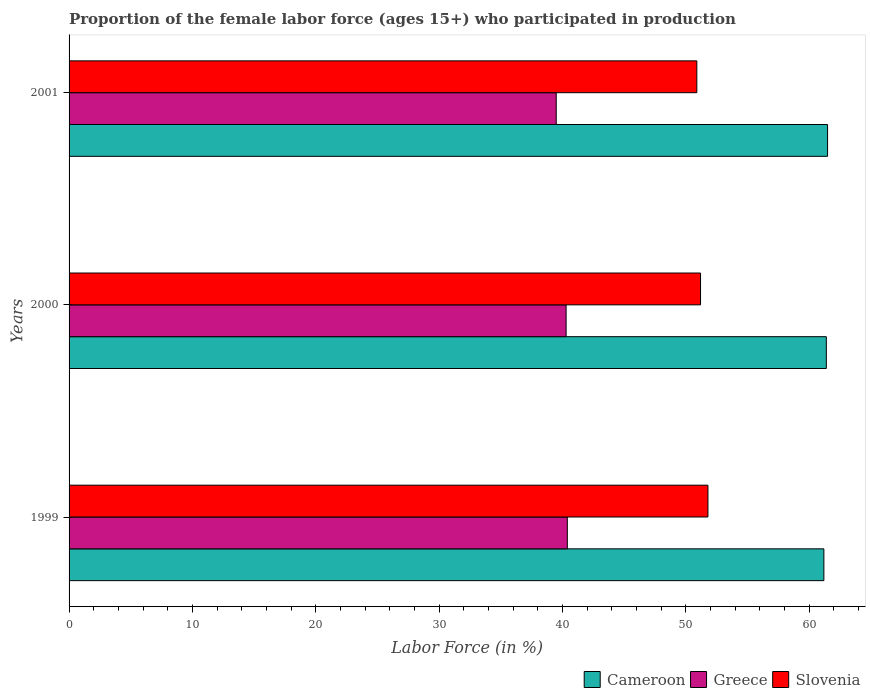How many groups of bars are there?
Make the answer very short. 3. Are the number of bars per tick equal to the number of legend labels?
Your answer should be very brief. Yes. How many bars are there on the 1st tick from the top?
Keep it short and to the point. 3. How many bars are there on the 2nd tick from the bottom?
Offer a terse response. 3. What is the label of the 2nd group of bars from the top?
Provide a short and direct response. 2000. What is the proportion of the female labor force who participated in production in Cameroon in 1999?
Provide a succinct answer. 61.2. Across all years, what is the maximum proportion of the female labor force who participated in production in Cameroon?
Make the answer very short. 61.5. Across all years, what is the minimum proportion of the female labor force who participated in production in Greece?
Make the answer very short. 39.5. In which year was the proportion of the female labor force who participated in production in Greece minimum?
Your answer should be compact. 2001. What is the total proportion of the female labor force who participated in production in Slovenia in the graph?
Ensure brevity in your answer.  153.9. What is the difference between the proportion of the female labor force who participated in production in Greece in 1999 and that in 2001?
Offer a very short reply. 0.9. What is the difference between the proportion of the female labor force who participated in production in Cameroon in 2000 and the proportion of the female labor force who participated in production in Slovenia in 1999?
Provide a short and direct response. 9.6. What is the average proportion of the female labor force who participated in production in Slovenia per year?
Provide a short and direct response. 51.3. In the year 1999, what is the difference between the proportion of the female labor force who participated in production in Greece and proportion of the female labor force who participated in production in Slovenia?
Ensure brevity in your answer.  -11.4. In how many years, is the proportion of the female labor force who participated in production in Greece greater than 24 %?
Keep it short and to the point. 3. What is the ratio of the proportion of the female labor force who participated in production in Slovenia in 2000 to that in 2001?
Keep it short and to the point. 1.01. Is the proportion of the female labor force who participated in production in Slovenia in 2000 less than that in 2001?
Your answer should be very brief. No. What is the difference between the highest and the second highest proportion of the female labor force who participated in production in Cameroon?
Offer a terse response. 0.1. What is the difference between the highest and the lowest proportion of the female labor force who participated in production in Slovenia?
Offer a terse response. 0.9. Is the sum of the proportion of the female labor force who participated in production in Slovenia in 2000 and 2001 greater than the maximum proportion of the female labor force who participated in production in Cameroon across all years?
Your response must be concise. Yes. What does the 2nd bar from the top in 2000 represents?
Offer a very short reply. Greece. What does the 1st bar from the bottom in 2001 represents?
Your answer should be very brief. Cameroon. Is it the case that in every year, the sum of the proportion of the female labor force who participated in production in Slovenia and proportion of the female labor force who participated in production in Cameroon is greater than the proportion of the female labor force who participated in production in Greece?
Your response must be concise. Yes. How many years are there in the graph?
Ensure brevity in your answer.  3. What is the difference between two consecutive major ticks on the X-axis?
Provide a succinct answer. 10. How many legend labels are there?
Your answer should be very brief. 3. What is the title of the graph?
Give a very brief answer. Proportion of the female labor force (ages 15+) who participated in production. Does "India" appear as one of the legend labels in the graph?
Your answer should be compact. No. What is the label or title of the X-axis?
Your answer should be compact. Labor Force (in %). What is the Labor Force (in %) of Cameroon in 1999?
Your answer should be very brief. 61.2. What is the Labor Force (in %) of Greece in 1999?
Offer a terse response. 40.4. What is the Labor Force (in %) in Slovenia in 1999?
Your answer should be very brief. 51.8. What is the Labor Force (in %) of Cameroon in 2000?
Offer a terse response. 61.4. What is the Labor Force (in %) in Greece in 2000?
Make the answer very short. 40.3. What is the Labor Force (in %) of Slovenia in 2000?
Offer a terse response. 51.2. What is the Labor Force (in %) of Cameroon in 2001?
Offer a very short reply. 61.5. What is the Labor Force (in %) in Greece in 2001?
Provide a short and direct response. 39.5. What is the Labor Force (in %) in Slovenia in 2001?
Your answer should be compact. 50.9. Across all years, what is the maximum Labor Force (in %) of Cameroon?
Your response must be concise. 61.5. Across all years, what is the maximum Labor Force (in %) of Greece?
Provide a succinct answer. 40.4. Across all years, what is the maximum Labor Force (in %) in Slovenia?
Give a very brief answer. 51.8. Across all years, what is the minimum Labor Force (in %) of Cameroon?
Offer a very short reply. 61.2. Across all years, what is the minimum Labor Force (in %) in Greece?
Your response must be concise. 39.5. Across all years, what is the minimum Labor Force (in %) in Slovenia?
Keep it short and to the point. 50.9. What is the total Labor Force (in %) in Cameroon in the graph?
Your answer should be compact. 184.1. What is the total Labor Force (in %) of Greece in the graph?
Offer a terse response. 120.2. What is the total Labor Force (in %) of Slovenia in the graph?
Your response must be concise. 153.9. What is the difference between the Labor Force (in %) of Greece in 1999 and that in 2001?
Provide a succinct answer. 0.9. What is the difference between the Labor Force (in %) in Slovenia in 1999 and that in 2001?
Keep it short and to the point. 0.9. What is the difference between the Labor Force (in %) of Greece in 2000 and that in 2001?
Give a very brief answer. 0.8. What is the difference between the Labor Force (in %) in Slovenia in 2000 and that in 2001?
Provide a succinct answer. 0.3. What is the difference between the Labor Force (in %) of Cameroon in 1999 and the Labor Force (in %) of Greece in 2000?
Provide a short and direct response. 20.9. What is the difference between the Labor Force (in %) in Cameroon in 1999 and the Labor Force (in %) in Slovenia in 2000?
Your answer should be compact. 10. What is the difference between the Labor Force (in %) in Greece in 1999 and the Labor Force (in %) in Slovenia in 2000?
Provide a succinct answer. -10.8. What is the difference between the Labor Force (in %) of Cameroon in 1999 and the Labor Force (in %) of Greece in 2001?
Provide a succinct answer. 21.7. What is the difference between the Labor Force (in %) in Greece in 1999 and the Labor Force (in %) in Slovenia in 2001?
Your answer should be very brief. -10.5. What is the difference between the Labor Force (in %) of Cameroon in 2000 and the Labor Force (in %) of Greece in 2001?
Offer a very short reply. 21.9. What is the difference between the Labor Force (in %) of Greece in 2000 and the Labor Force (in %) of Slovenia in 2001?
Provide a short and direct response. -10.6. What is the average Labor Force (in %) in Cameroon per year?
Provide a short and direct response. 61.37. What is the average Labor Force (in %) of Greece per year?
Your answer should be compact. 40.07. What is the average Labor Force (in %) in Slovenia per year?
Make the answer very short. 51.3. In the year 1999, what is the difference between the Labor Force (in %) in Cameroon and Labor Force (in %) in Greece?
Make the answer very short. 20.8. In the year 1999, what is the difference between the Labor Force (in %) of Cameroon and Labor Force (in %) of Slovenia?
Ensure brevity in your answer.  9.4. In the year 1999, what is the difference between the Labor Force (in %) in Greece and Labor Force (in %) in Slovenia?
Ensure brevity in your answer.  -11.4. In the year 2000, what is the difference between the Labor Force (in %) of Cameroon and Labor Force (in %) of Greece?
Provide a succinct answer. 21.1. In the year 2000, what is the difference between the Labor Force (in %) in Cameroon and Labor Force (in %) in Slovenia?
Offer a very short reply. 10.2. In the year 2000, what is the difference between the Labor Force (in %) in Greece and Labor Force (in %) in Slovenia?
Your response must be concise. -10.9. In the year 2001, what is the difference between the Labor Force (in %) of Cameroon and Labor Force (in %) of Greece?
Provide a succinct answer. 22. What is the ratio of the Labor Force (in %) in Greece in 1999 to that in 2000?
Keep it short and to the point. 1. What is the ratio of the Labor Force (in %) of Slovenia in 1999 to that in 2000?
Keep it short and to the point. 1.01. What is the ratio of the Labor Force (in %) in Greece in 1999 to that in 2001?
Offer a very short reply. 1.02. What is the ratio of the Labor Force (in %) of Slovenia in 1999 to that in 2001?
Ensure brevity in your answer.  1.02. What is the ratio of the Labor Force (in %) in Cameroon in 2000 to that in 2001?
Give a very brief answer. 1. What is the ratio of the Labor Force (in %) in Greece in 2000 to that in 2001?
Give a very brief answer. 1.02. What is the ratio of the Labor Force (in %) in Slovenia in 2000 to that in 2001?
Your response must be concise. 1.01. What is the difference between the highest and the second highest Labor Force (in %) in Cameroon?
Your response must be concise. 0.1. What is the difference between the highest and the second highest Labor Force (in %) in Greece?
Provide a succinct answer. 0.1. What is the difference between the highest and the second highest Labor Force (in %) of Slovenia?
Make the answer very short. 0.6. What is the difference between the highest and the lowest Labor Force (in %) of Greece?
Provide a short and direct response. 0.9. 